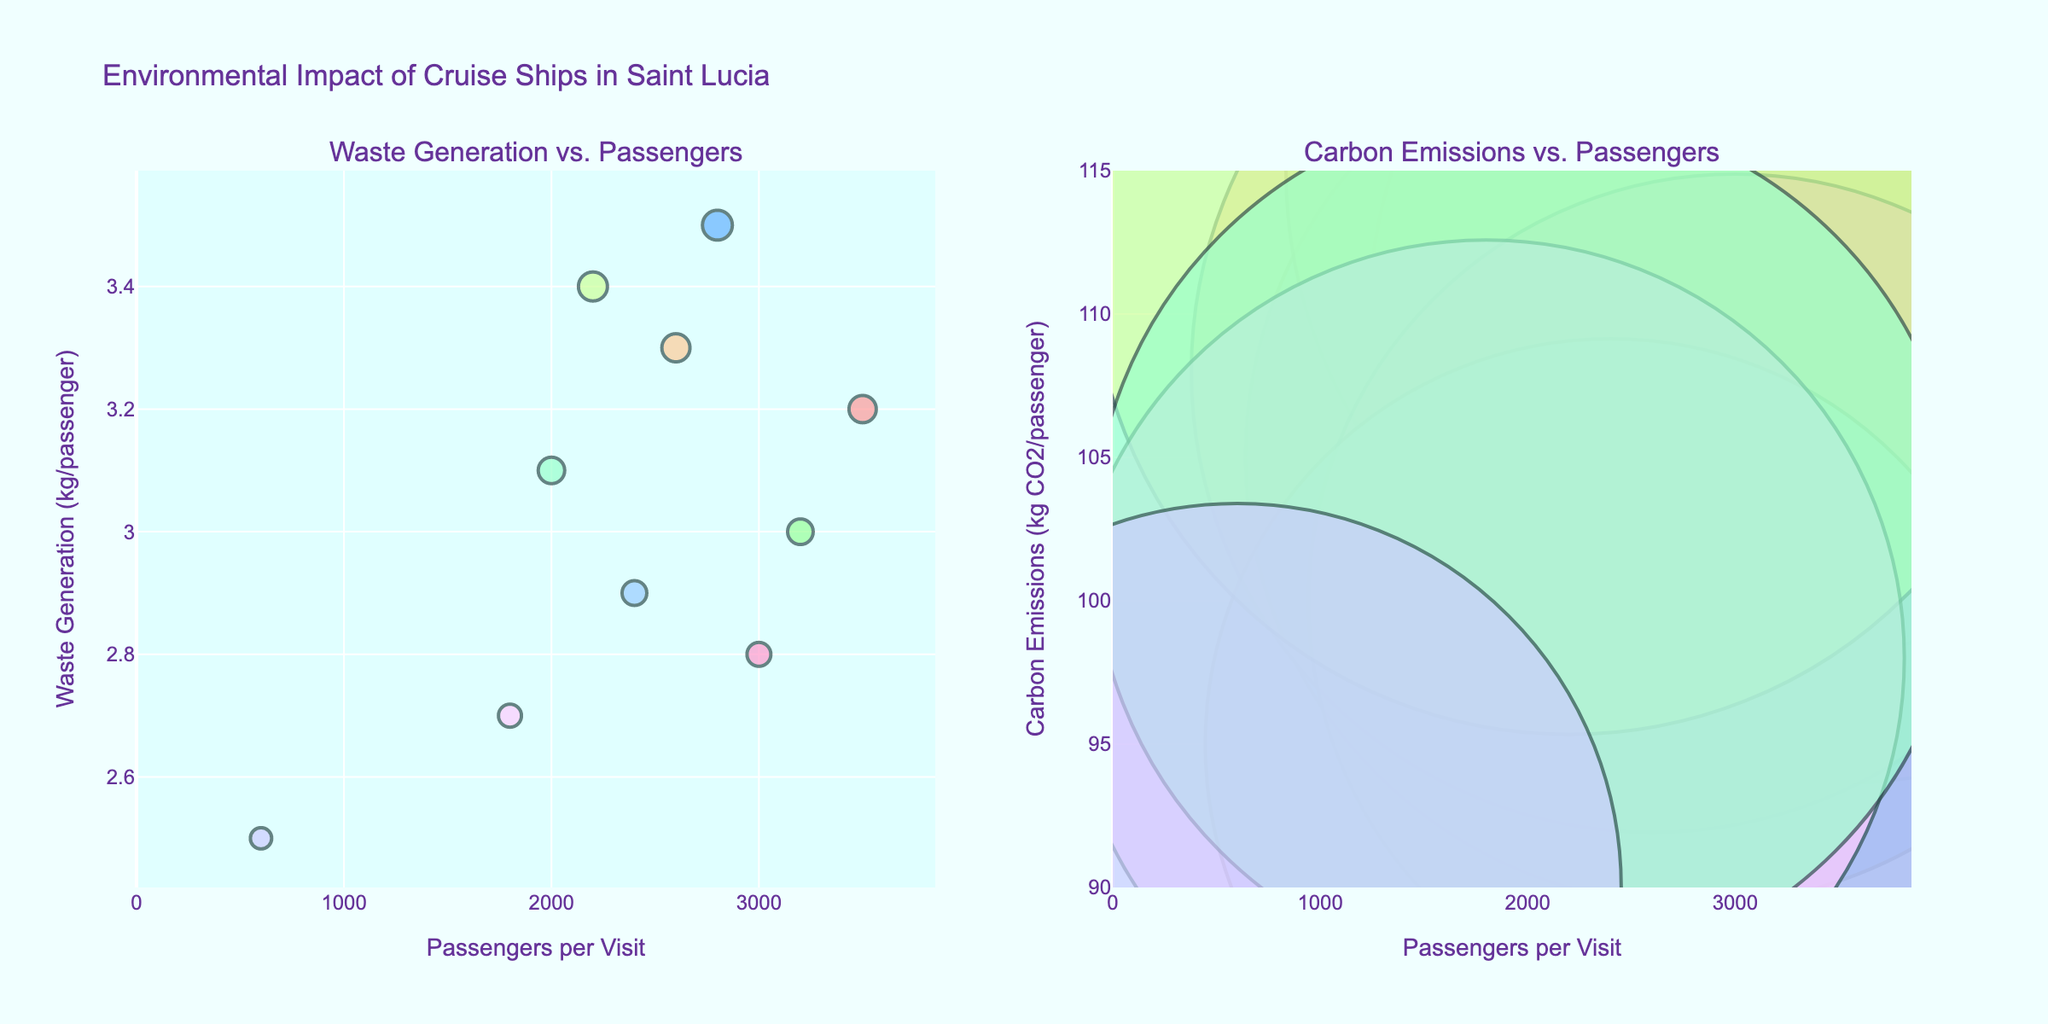What's the title of the figure? The title of the figure is prominently displayed at the top. It reads "Environmental Impact of Cruise Ships in Saint Lucia."
Answer: Environmental Impact of Cruise Ships in Saint Lucia How many bubbles are displayed in the left subplot? The left subplot shows each bubble representing a cruise line and is labeled "Waste Generation vs. Passengers." Count the number of bubbles present in this subplot.
Answer: 10 Which cruise line has the lowest waste generation per passenger? The left subplot shows the waste generation per passenger on the y-axis. Find the bubble that is lowest on this axis, and check its label using the hover text or legend.
Answer: Seabourn Cruise Line What is the range of passengers per visit across all cruise lines? Look at the x-axis, "Passengers per Visit," and identify the minimum and maximum values. The lowest is 600 (Seabourn Cruise Line) and the highest is 3500 (Royal Caribbean).
Answer: 600 to 3500 Which cruise line has the highest carbon emissions per passenger? The right subplot shows "Carbon Emissions vs. Passengers" on the y-axis. Identify the bubble that is highest on the y-axis, and check its label using hover text or the legend.
Answer: Norwegian Cruise Line What is the difference in waste generation per passenger between Carnival Cruise Line and Celebrity Cruises? Identify the waste generation values for both lines from the left subplot: Carnival Cruise Line has 3.5 kg/passenger, and Celebrity Cruises has 2.9 kg/passenger. Subtract these: 3.5 - 2.9.
Answer: 0.6 kg/passenger Which port of call hosts the most cruise lines according to the figure? Review the hover text or legend for each bubble to see the port of call. Count the occurrences for each port: Castries (3), Soufriere (2), Rodney Bay (2), Vieux Fort (1), Marigot Bay (2).
Answer: Castries Are there any ports of call that have both high and low carbon emission cruise lines? Check the right subplot and note the ports of call using hover text or legend for each bubble. Look for significant differences in emission values among the same port of call: Marigot Bay has Celebrity Cruises (95 kg CO2/passenger) and Seabourn Cruise Line (90 kg CO2/passenger).
Answer: Marigot Bay What is the sum of passengers per visit for all cruise lines? Add the number of passengers per visit for each cruise line: 3500 (Royal Caribbean) + 2800 (Carnival) + 3200 (Norwegian) + 2600 (MSC) + 3000 (Princess) + 2400 (Celebrity) + 2200 (Costa) + 1800 (Holland America) + 2000 (Disney) + 600 (Seabourn).
Answer: 24100 Which cruise line at Castries has lower waste generation per passenger? Look at the bubbles labeled for Castries in the left subplot. Check their y-axis values. Royal Caribbean (3.2 kg) and Disney Cruise Line (3.1 kg). Review these values.
Answer: Disney Cruise Line 